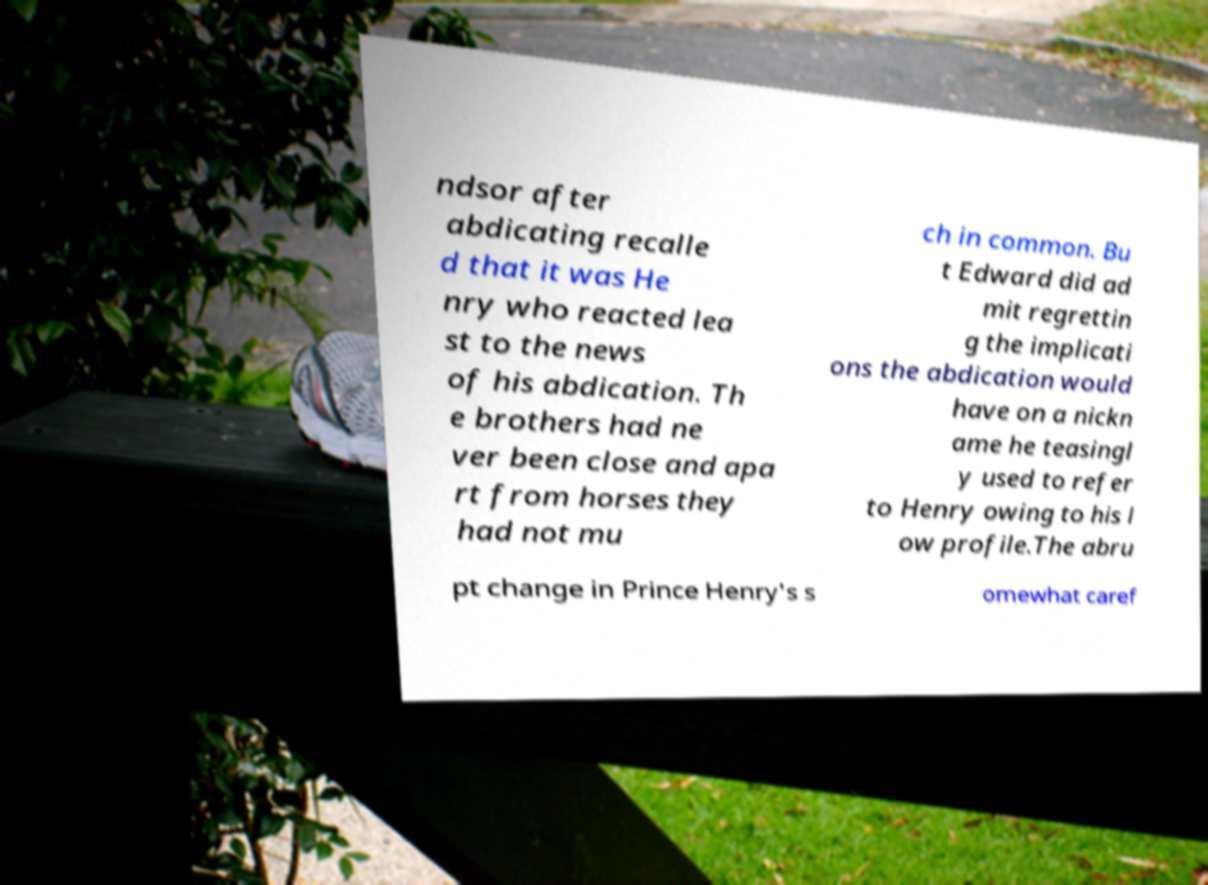Could you extract and type out the text from this image? ndsor after abdicating recalle d that it was He nry who reacted lea st to the news of his abdication. Th e brothers had ne ver been close and apa rt from horses they had not mu ch in common. Bu t Edward did ad mit regrettin g the implicati ons the abdication would have on a nickn ame he teasingl y used to refer to Henry owing to his l ow profile.The abru pt change in Prince Henry's s omewhat caref 